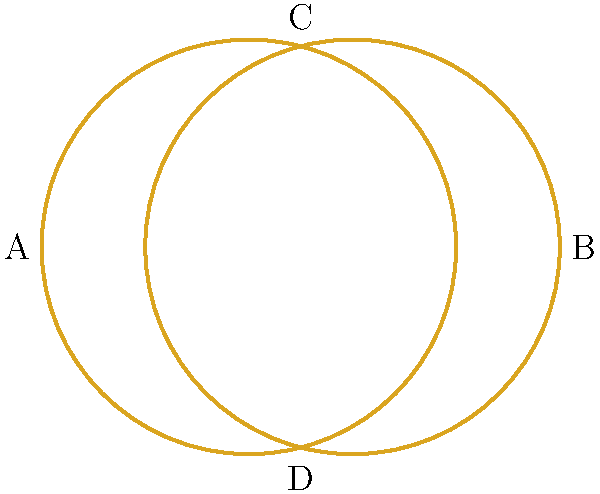In the context of a romantic screenplay, two intertwined wedding rings are represented topologically as shown above. If we consider the rings as closed curves on a plane, how many regions does this arrangement divide the plane into? To determine the number of regions, we can follow these steps:

1. Identify the intersection points: The two circles intersect at two points (C and D in the diagram).

2. Count the arcs: Between these intersection points, we have 4 arcs (2 from each circle).

3. Apply Euler's formula for planar graphs:
   $V - E + F = 2$
   Where V is the number of vertices (intersection points),
   E is the number of edges (arcs),
   and F is the number of faces (regions, including the outer region).

4. Substitute the known values:
   $2 - 4 + F = 2$

5. Solve for F:
   $F = 4$

Therefore, the intertwined rings divide the plane into 4 regions: the inner region (symbolizing the union of the couple), two "lense-shaped" regions (representing individual growth within the relationship), and the outer region (the world beyond their union).
Answer: 4 regions 